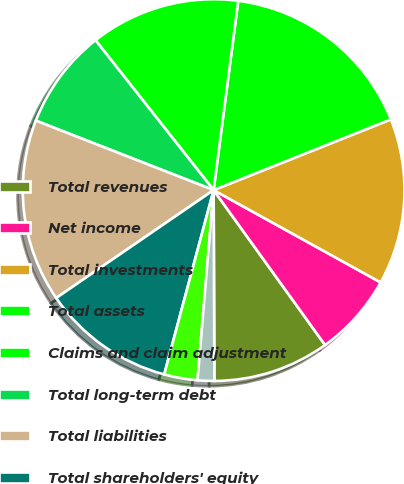<chart> <loc_0><loc_0><loc_500><loc_500><pie_chart><fcel>Total revenues<fcel>Net income<fcel>Total investments<fcel>Total assets<fcel>Claims and claim adjustment<fcel>Total long-term debt<fcel>Total liabilities<fcel>Total shareholders' equity<fcel>Basic<fcel>Diluted<nl><fcel>9.86%<fcel>7.04%<fcel>14.08%<fcel>16.9%<fcel>12.68%<fcel>8.45%<fcel>15.49%<fcel>11.27%<fcel>2.82%<fcel>1.41%<nl></chart> 